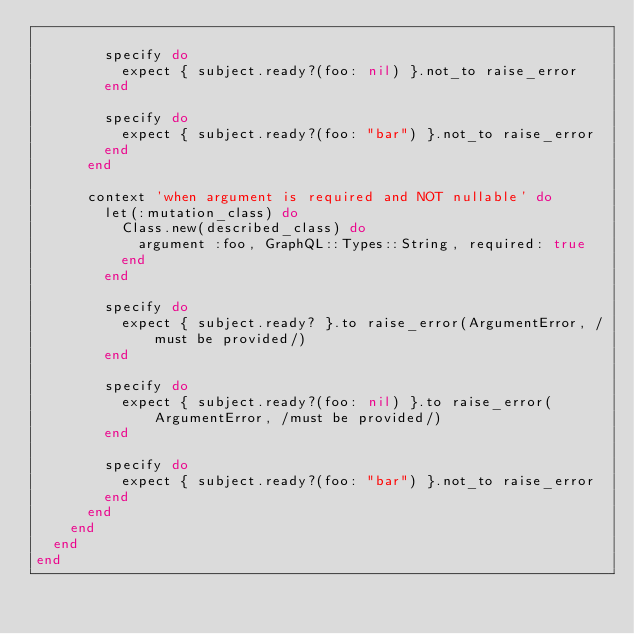Convert code to text. <code><loc_0><loc_0><loc_500><loc_500><_Ruby_>
        specify do
          expect { subject.ready?(foo: nil) }.not_to raise_error
        end

        specify do
          expect { subject.ready?(foo: "bar") }.not_to raise_error
        end
      end

      context 'when argument is required and NOT nullable' do
        let(:mutation_class) do
          Class.new(described_class) do
            argument :foo, GraphQL::Types::String, required: true
          end
        end

        specify do
          expect { subject.ready? }.to raise_error(ArgumentError, /must be provided/)
        end

        specify do
          expect { subject.ready?(foo: nil) }.to raise_error(ArgumentError, /must be provided/)
        end

        specify do
          expect { subject.ready?(foo: "bar") }.not_to raise_error
        end
      end
    end
  end
end
</code> 